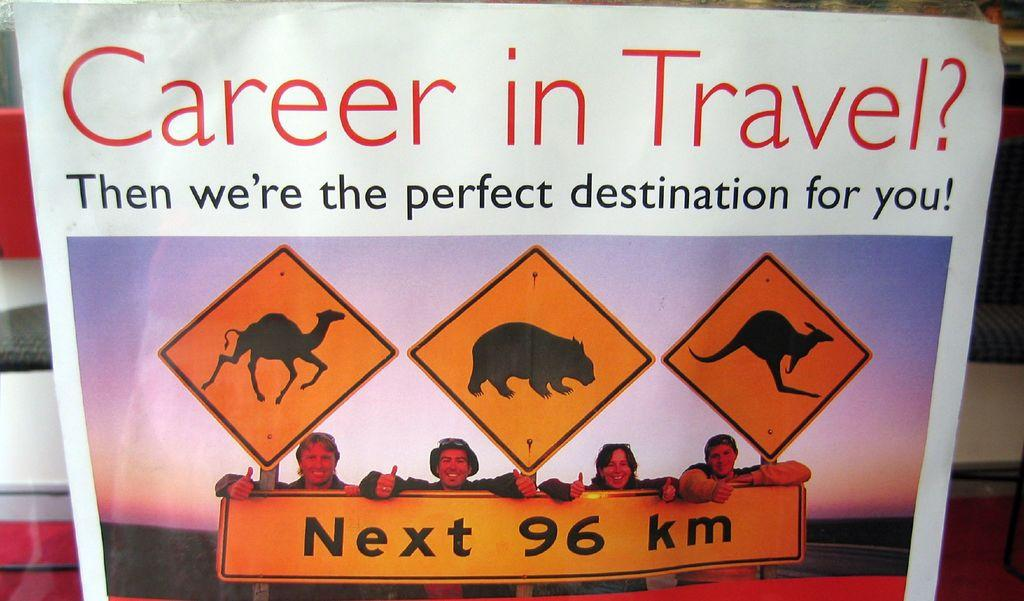<image>
Describe the image concisely. the word career on top of a paper 